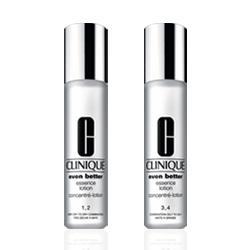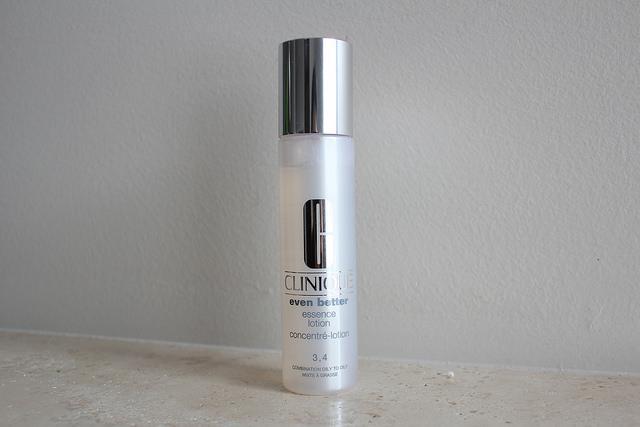The first image is the image on the left, the second image is the image on the right. Considering the images on both sides, is "An image shows a cylindrical upright bottle creating ripples in a pool of water." valid? Answer yes or no. No. The first image is the image on the left, the second image is the image on the right. For the images shown, is this caption "The right image contains no more than one slim container with a chrome top." true? Answer yes or no. Yes. 